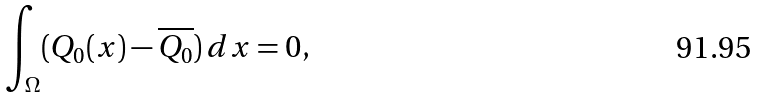<formula> <loc_0><loc_0><loc_500><loc_500>\int _ { \Omega } ( Q _ { 0 } ( x ) - \overline { Q _ { 0 } } ) \, d x = 0 ,</formula> 